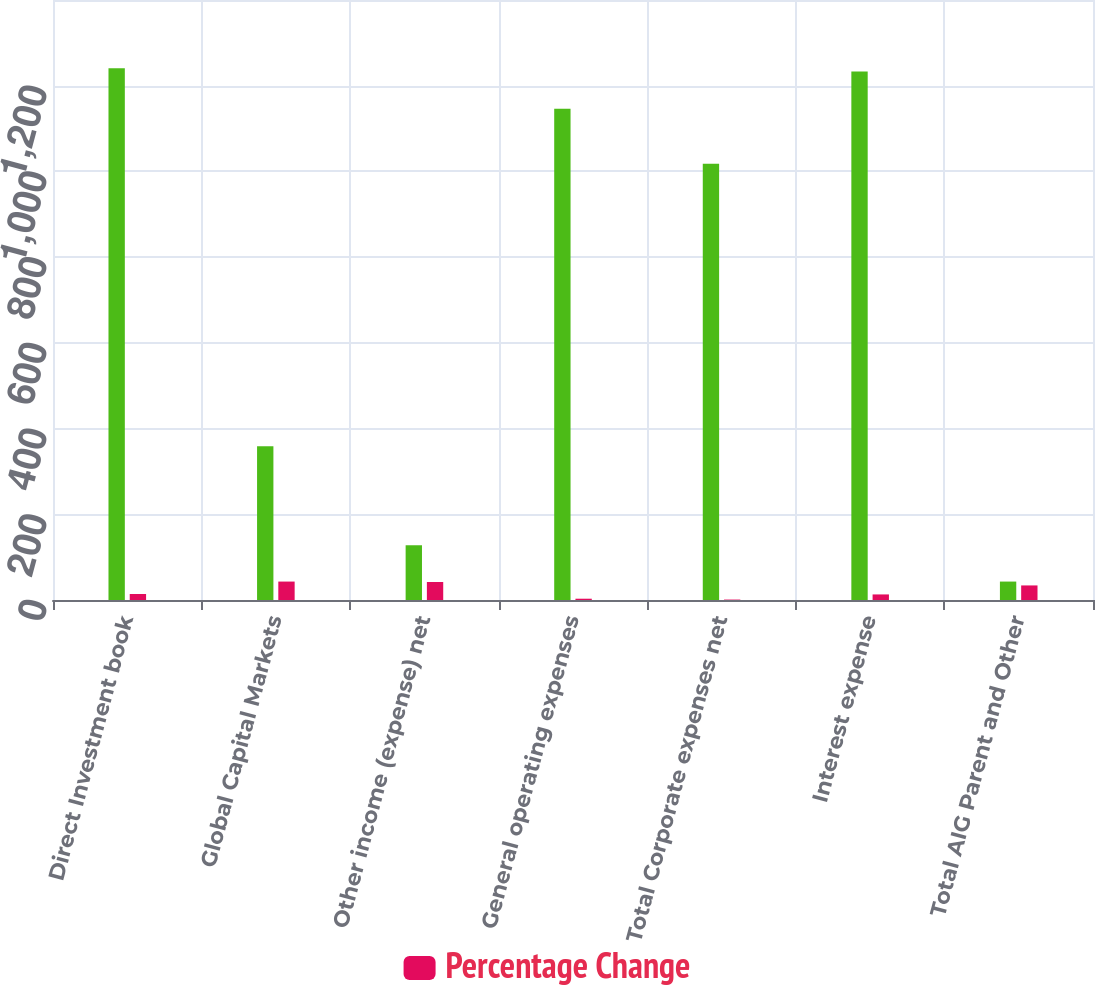Convert chart to OTSL. <chart><loc_0><loc_0><loc_500><loc_500><stacked_bar_chart><ecel><fcel>Direct Investment book<fcel>Global Capital Markets<fcel>Other income (expense) net<fcel>General operating expenses<fcel>Total Corporate expenses net<fcel>Interest expense<fcel>Total AIG Parent and Other<nl><fcel>nan<fcel>1241<fcel>359<fcel>128<fcel>1146<fcel>1018<fcel>1233<fcel>43<nl><fcel>Percentage Change<fcel>14<fcel>43<fcel>42<fcel>3<fcel>1<fcel>13<fcel>34<nl></chart> 